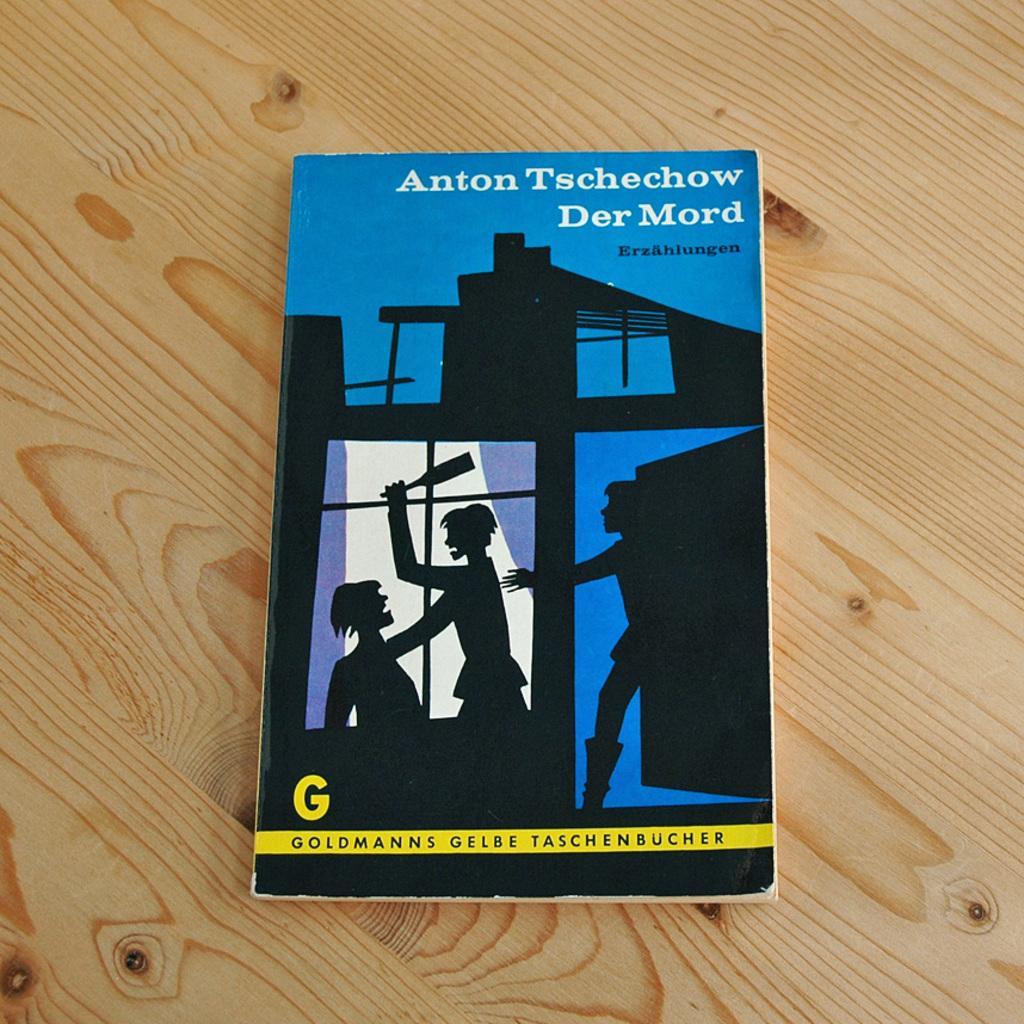What object is present in the image? There is a book in the image. On what type of surface is the book placed? The book is placed on a wooden surface. What can be seen on the book cover? There are images and text on the book cover. How does the sea contribute to the content of the book in the image? The image does not depict a sea or any marine elements, so it cannot be determined how the sea contributes to the content of the book. 